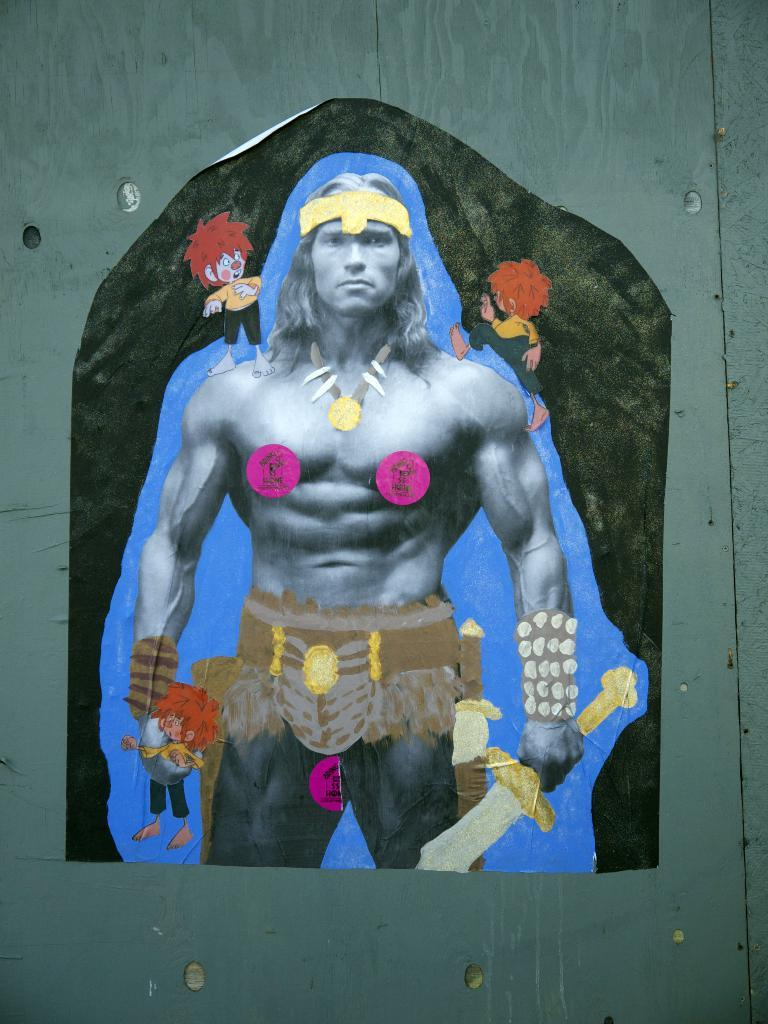What is the main subject in the center of the image? There is a poster in the center of the image. What is depicted on the poster? The poster features a person holding a sword. What color is the background of the image? The background of the image is green in color. What type of ink is used to write the person's name on the sword in the image? There is no person's name written on the sword in the image, and therefore no ink is used for that purpose. 